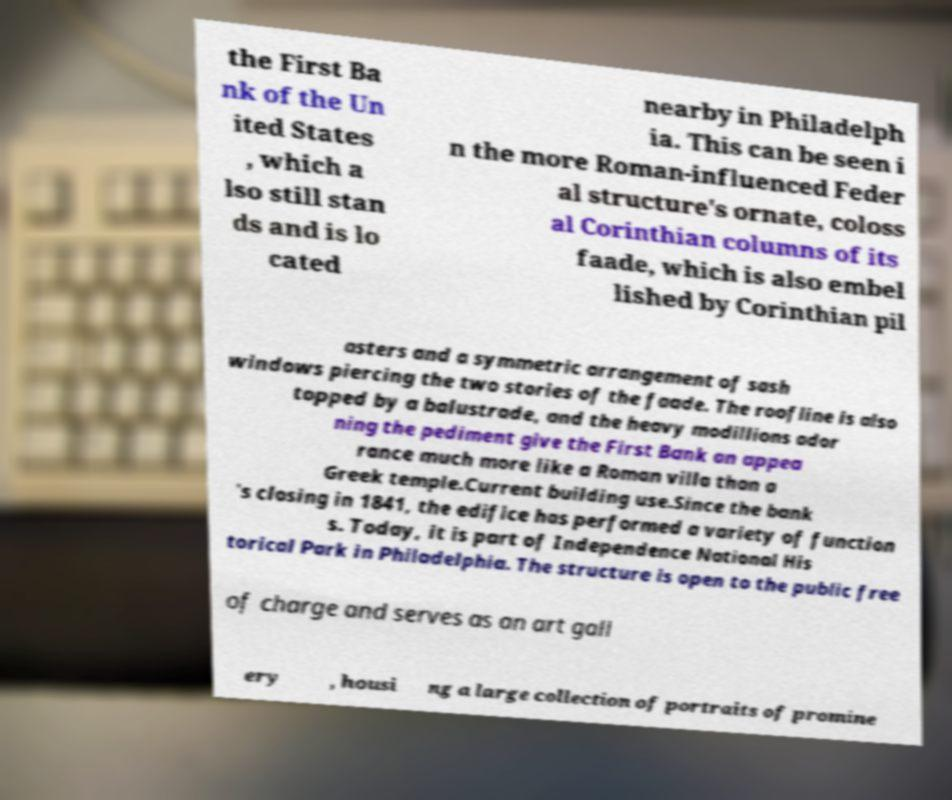For documentation purposes, I need the text within this image transcribed. Could you provide that? the First Ba nk of the Un ited States , which a lso still stan ds and is lo cated nearby in Philadelph ia. This can be seen i n the more Roman-influenced Feder al structure's ornate, coloss al Corinthian columns of its faade, which is also embel lished by Corinthian pil asters and a symmetric arrangement of sash windows piercing the two stories of the faade. The roofline is also topped by a balustrade, and the heavy modillions ador ning the pediment give the First Bank an appea rance much more like a Roman villa than a Greek temple.Current building use.Since the bank 's closing in 1841, the edifice has performed a variety of function s. Today, it is part of Independence National His torical Park in Philadelphia. The structure is open to the public free of charge and serves as an art gall ery , housi ng a large collection of portraits of promine 